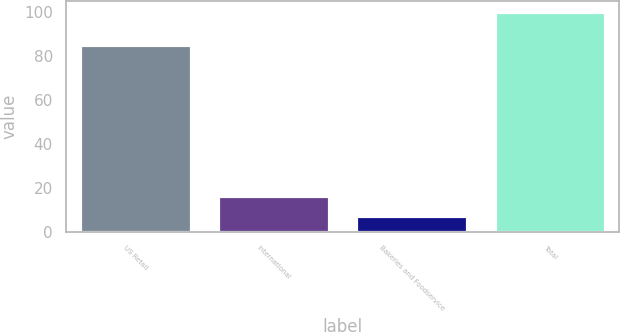Convert chart. <chart><loc_0><loc_0><loc_500><loc_500><bar_chart><fcel>US Retail<fcel>International<fcel>Bakeries and Foodservice<fcel>Total<nl><fcel>85<fcel>16.3<fcel>7<fcel>100<nl></chart> 